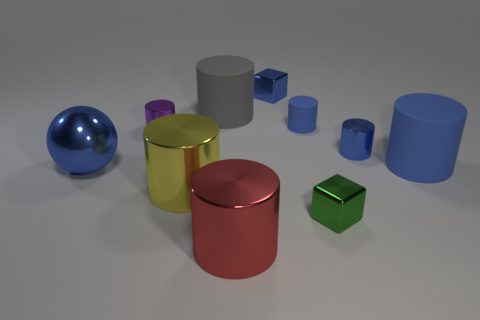How many blue cylinders must be subtracted to get 1 blue cylinders? 2 Subtract all large blue cylinders. How many cylinders are left? 6 Subtract all red cylinders. How many cylinders are left? 6 Subtract 1 cubes. How many cubes are left? 1 Add 4 red metal objects. How many red metal objects exist? 5 Subtract 0 yellow spheres. How many objects are left? 10 Subtract all cylinders. How many objects are left? 3 Subtract all blue cubes. Subtract all cyan balls. How many cubes are left? 1 Subtract all blue balls. How many blue cylinders are left? 3 Subtract all small brown matte balls. Subtract all yellow metal cylinders. How many objects are left? 9 